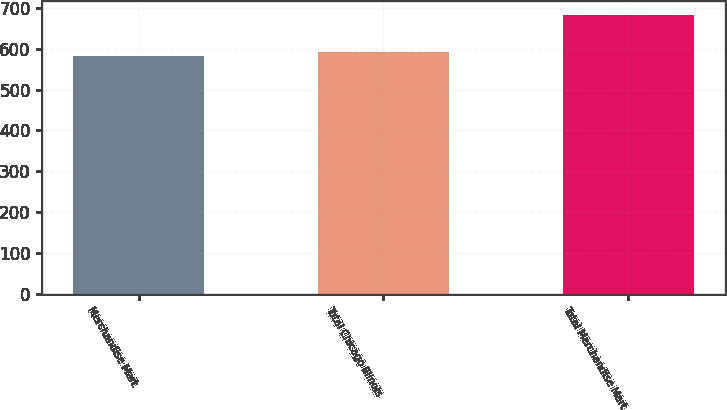<chart> <loc_0><loc_0><loc_500><loc_500><bar_chart><fcel>Merchandise Mart<fcel>Total Chicago Illinois<fcel>Total Merchandise Mart<nl><fcel>582<fcel>592.1<fcel>683<nl></chart> 